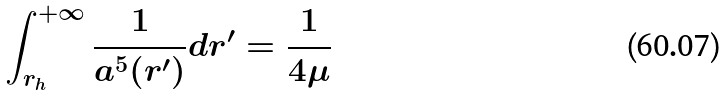Convert formula to latex. <formula><loc_0><loc_0><loc_500><loc_500>\int _ { r _ { h } } ^ { + \infty } \frac { 1 } { a ^ { 5 } ( r ^ { \prime } ) } d r ^ { \prime } = \frac { 1 } { 4 \mu }</formula> 